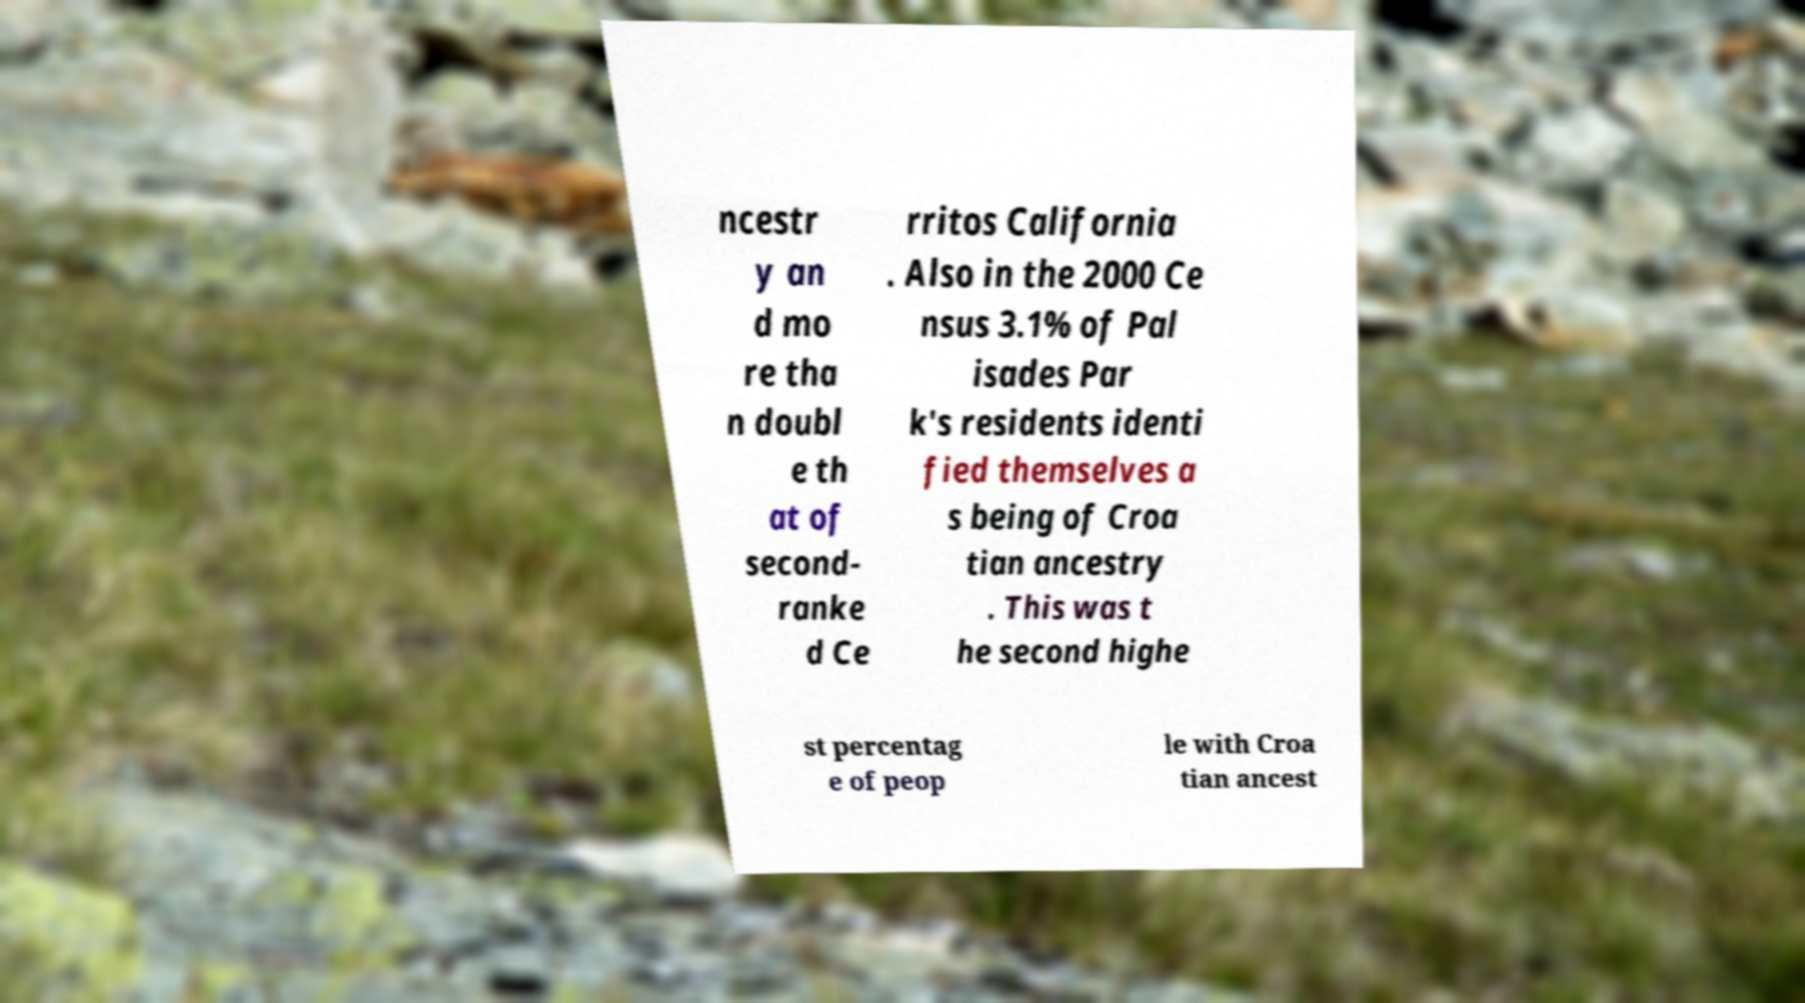What messages or text are displayed in this image? I need them in a readable, typed format. ncestr y an d mo re tha n doubl e th at of second- ranke d Ce rritos California . Also in the 2000 Ce nsus 3.1% of Pal isades Par k's residents identi fied themselves a s being of Croa tian ancestry . This was t he second highe st percentag e of peop le with Croa tian ancest 